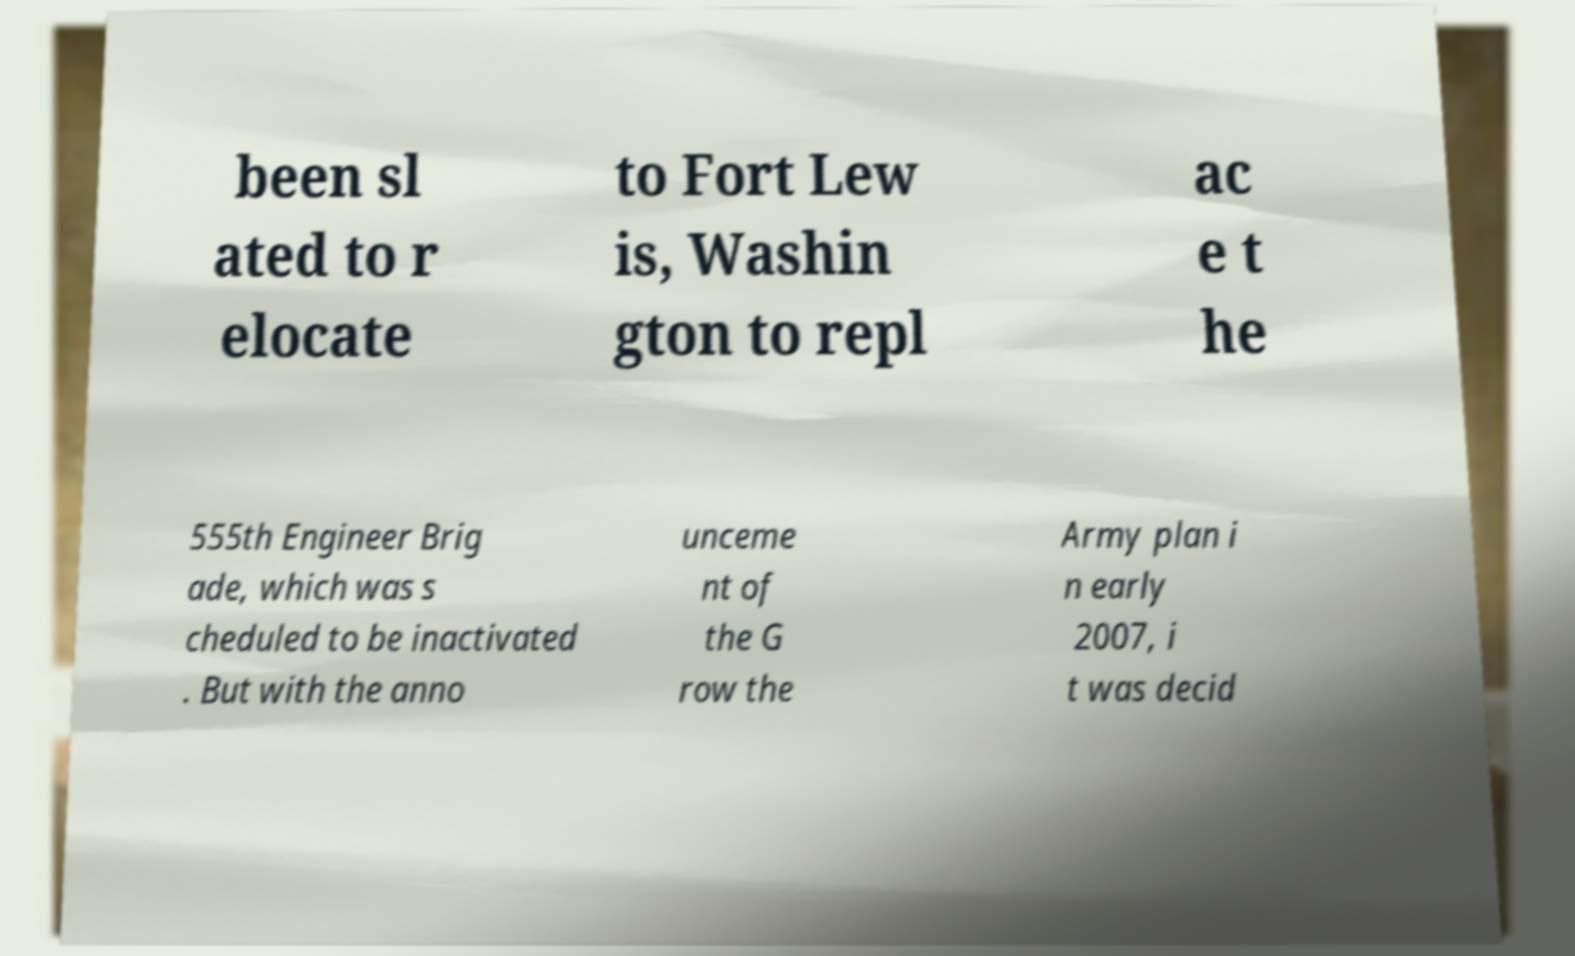Can you accurately transcribe the text from the provided image for me? been sl ated to r elocate to Fort Lew is, Washin gton to repl ac e t he 555th Engineer Brig ade, which was s cheduled to be inactivated . But with the anno unceme nt of the G row the Army plan i n early 2007, i t was decid 